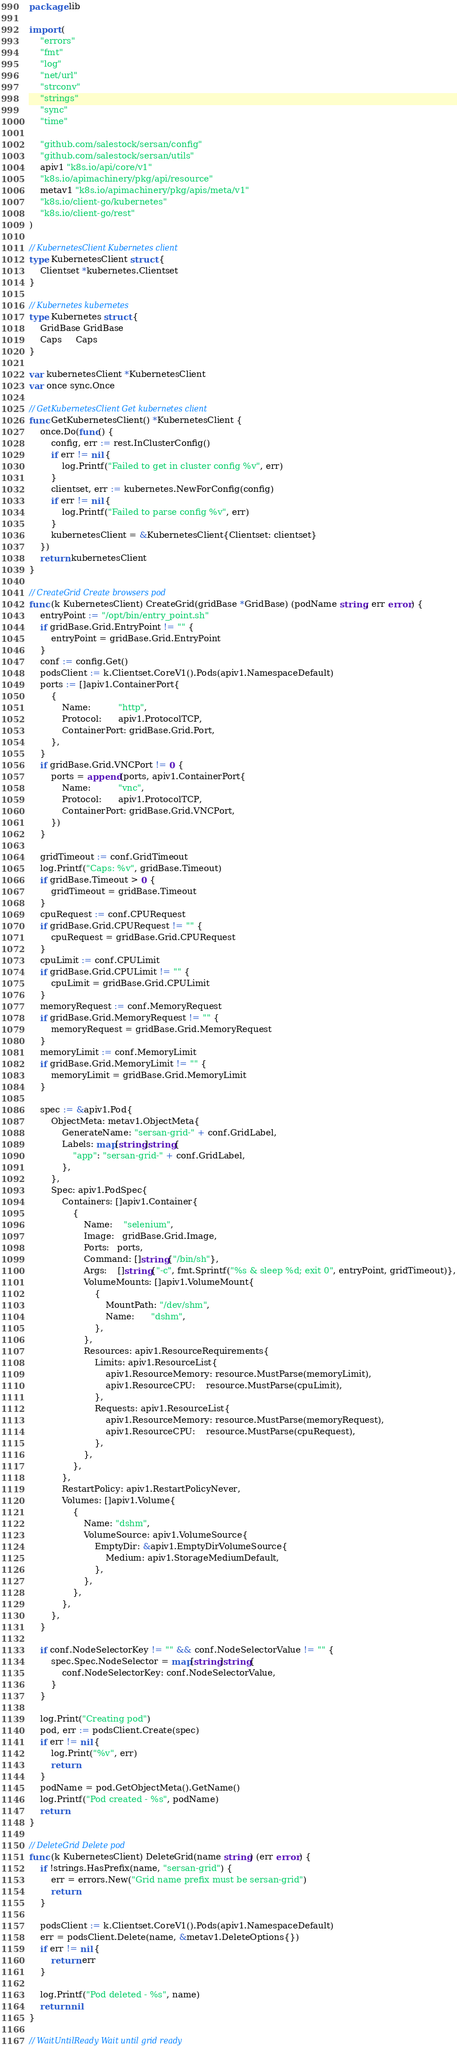<code> <loc_0><loc_0><loc_500><loc_500><_Go_>package lib

import (
	"errors"
	"fmt"
	"log"
	"net/url"
	"strconv"
	"strings"
	"sync"
	"time"

	"github.com/salestock/sersan/config"
	"github.com/salestock/sersan/utils"
	apiv1 "k8s.io/api/core/v1"
	"k8s.io/apimachinery/pkg/api/resource"
	metav1 "k8s.io/apimachinery/pkg/apis/meta/v1"
	"k8s.io/client-go/kubernetes"
	"k8s.io/client-go/rest"
)

// KubernetesClient Kubernetes client
type KubernetesClient struct {
	Clientset *kubernetes.Clientset
}

// Kubernetes kubernetes
type Kubernetes struct {
	GridBase GridBase
	Caps     Caps
}

var kubernetesClient *KubernetesClient
var once sync.Once

// GetKubernetesClient Get kubernetes client
func GetKubernetesClient() *KubernetesClient {
	once.Do(func() {
		config, err := rest.InClusterConfig()
		if err != nil {
			log.Printf("Failed to get in cluster config %v", err)
		}
		clientset, err := kubernetes.NewForConfig(config)
		if err != nil {
			log.Printf("Failed to parse config %v", err)
		}
		kubernetesClient = &KubernetesClient{Clientset: clientset}
	})
	return kubernetesClient
}

// CreateGrid Create browsers pod
func (k KubernetesClient) CreateGrid(gridBase *GridBase) (podName string, err error) {
	entryPoint := "/opt/bin/entry_point.sh"
	if gridBase.Grid.EntryPoint != "" {
		entryPoint = gridBase.Grid.EntryPoint
	}
	conf := config.Get()
	podsClient := k.Clientset.CoreV1().Pods(apiv1.NamespaceDefault)
	ports := []apiv1.ContainerPort{
		{
			Name:          "http",
			Protocol:      apiv1.ProtocolTCP,
			ContainerPort: gridBase.Grid.Port,
		},
	}
	if gridBase.Grid.VNCPort != 0 {
		ports = append(ports, apiv1.ContainerPort{
			Name:          "vnc",
			Protocol:      apiv1.ProtocolTCP,
			ContainerPort: gridBase.Grid.VNCPort,
		})
	}

	gridTimeout := conf.GridTimeout
	log.Printf("Caps: %v", gridBase.Timeout)
	if gridBase.Timeout > 0 {
		gridTimeout = gridBase.Timeout
	}
	cpuRequest := conf.CPURequest
	if gridBase.Grid.CPURequest != "" {
		cpuRequest = gridBase.Grid.CPURequest
	}
	cpuLimit := conf.CPULimit
	if gridBase.Grid.CPULimit != "" {
		cpuLimit = gridBase.Grid.CPULimit
	}
	memoryRequest := conf.MemoryRequest
	if gridBase.Grid.MemoryRequest != "" {
		memoryRequest = gridBase.Grid.MemoryRequest
	}
	memoryLimit := conf.MemoryLimit
	if gridBase.Grid.MemoryLimit != "" {
		memoryLimit = gridBase.Grid.MemoryLimit
	}

	spec := &apiv1.Pod{
		ObjectMeta: metav1.ObjectMeta{
			GenerateName: "sersan-grid-" + conf.GridLabel,
			Labels: map[string]string{
				"app": "sersan-grid-" + conf.GridLabel,
			},
		},
		Spec: apiv1.PodSpec{
			Containers: []apiv1.Container{
				{
					Name:    "selenium",
					Image:   gridBase.Grid.Image,
					Ports:   ports,
					Command: []string{"/bin/sh"},
					Args:    []string{"-c", fmt.Sprintf("%s & sleep %d; exit 0", entryPoint, gridTimeout)},
					VolumeMounts: []apiv1.VolumeMount{
						{
							MountPath: "/dev/shm",
							Name:      "dshm",
						},
					},
					Resources: apiv1.ResourceRequirements{
						Limits: apiv1.ResourceList{
							apiv1.ResourceMemory: resource.MustParse(memoryLimit),
							apiv1.ResourceCPU:    resource.MustParse(cpuLimit),
						},
						Requests: apiv1.ResourceList{
							apiv1.ResourceMemory: resource.MustParse(memoryRequest),
							apiv1.ResourceCPU:    resource.MustParse(cpuRequest),
						},
					},
				},
			},
			RestartPolicy: apiv1.RestartPolicyNever,
			Volumes: []apiv1.Volume{
				{
					Name: "dshm",
					VolumeSource: apiv1.VolumeSource{
						EmptyDir: &apiv1.EmptyDirVolumeSource{
							Medium: apiv1.StorageMediumDefault,
						},
					},
				},
			},
		},
	}

	if conf.NodeSelectorKey != "" && conf.NodeSelectorValue != "" {
		spec.Spec.NodeSelector = map[string]string{
			conf.NodeSelectorKey: conf.NodeSelectorValue,
		}
	}

	log.Print("Creating pod")
	pod, err := podsClient.Create(spec)
	if err != nil {
		log.Print("%v", err)
		return
	}
	podName = pod.GetObjectMeta().GetName()
	log.Printf("Pod created - %s", podName)
	return
}

// DeleteGrid Delete pod
func (k KubernetesClient) DeleteGrid(name string) (err error) {
	if !strings.HasPrefix(name, "sersan-grid") {
		err = errors.New("Grid name prefix must be sersan-grid")
		return
	}

	podsClient := k.Clientset.CoreV1().Pods(apiv1.NamespaceDefault)
	err = podsClient.Delete(name, &metav1.DeleteOptions{})
	if err != nil {
		return err
	}

	log.Printf("Pod deleted - %s", name)
	return nil
}

// WaitUntilReady Wait until grid ready</code> 